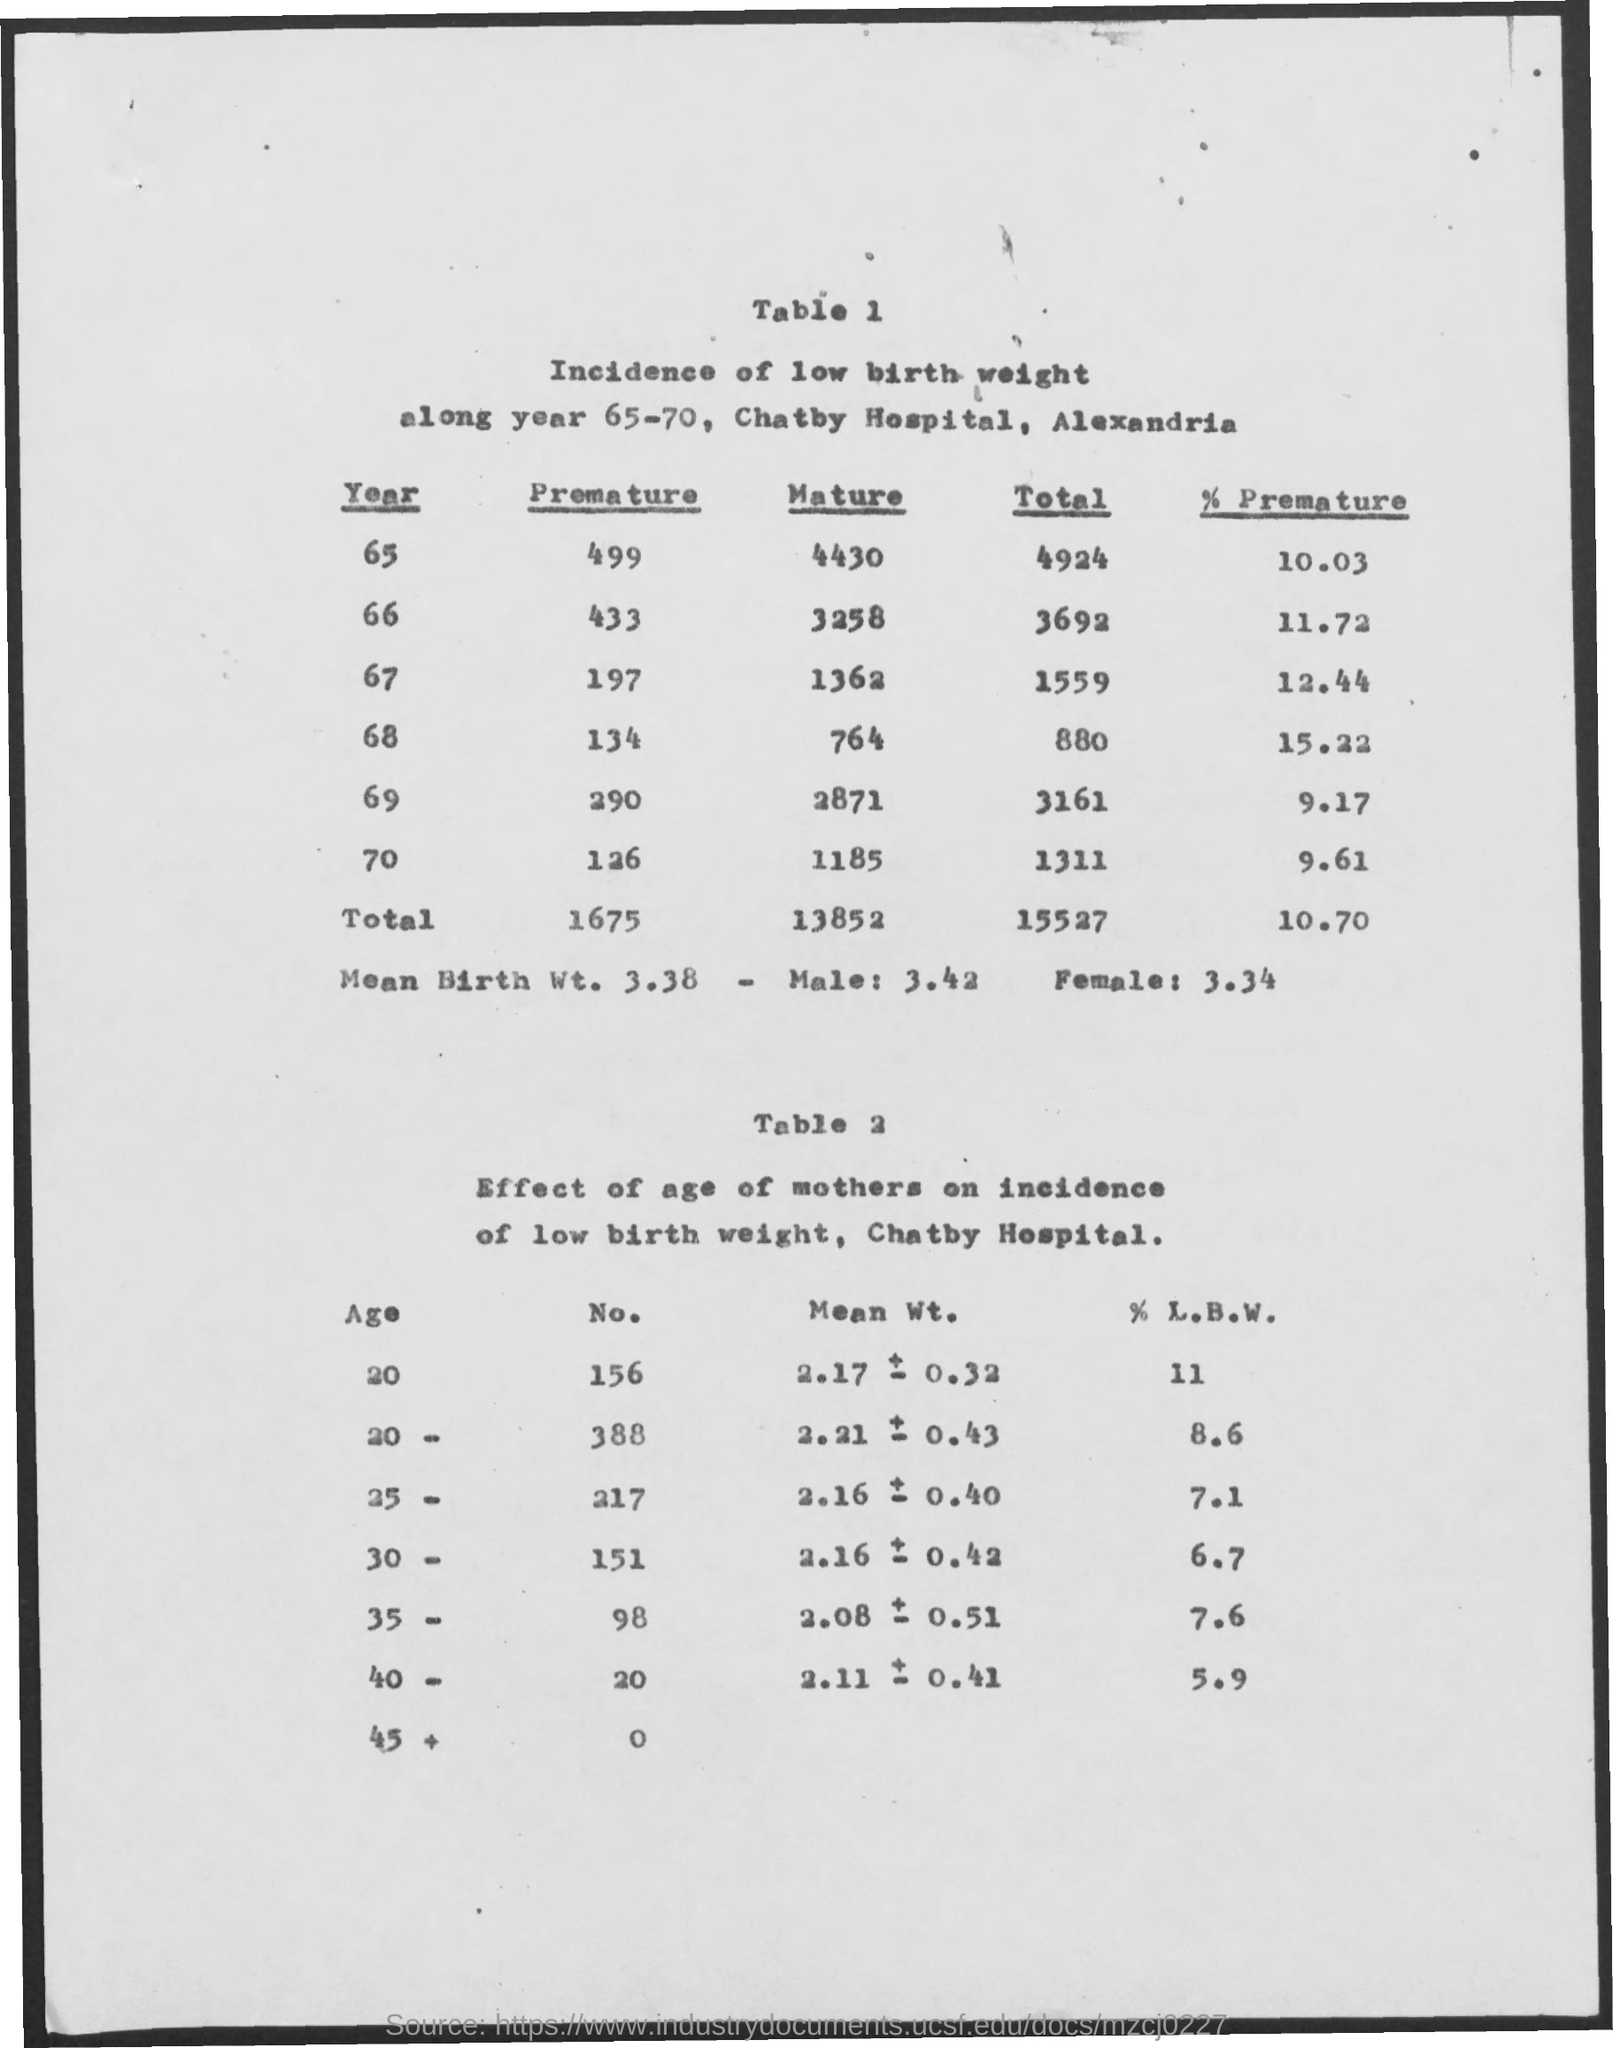What is the name of the hospital ?
Make the answer very short. CHATBY HOSPITAL. What is the total no of births in the year 65
Give a very brief answer. 4924. How much is the total of premature births from the years 65-70
Your response must be concise. 1675. What is the total of mature births for the year 65-70
Provide a short and direct response. 13852. What is the % l.b.w for the age 20 for the no 156
Your answer should be compact. 11. 